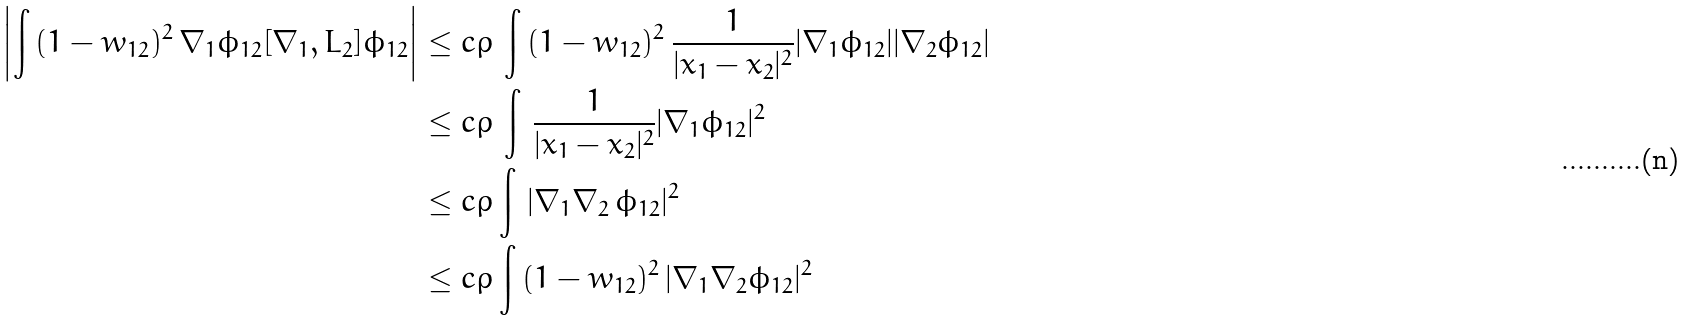Convert formula to latex. <formula><loc_0><loc_0><loc_500><loc_500>\left | \int \, ( 1 - w _ { 1 2 } ) ^ { 2 } \, \nabla _ { 1 } \phi _ { 1 2 } [ \nabla _ { 1 } , L _ { 2 } ] \phi _ { 1 2 } \right | & \leq c \rho \, \int \, ( 1 - w _ { 1 2 } ) ^ { 2 } \, \frac { 1 } { | x _ { 1 } - x _ { 2 } | ^ { 2 } } | \nabla _ { 1 } \phi _ { 1 2 } | | \nabla _ { 2 } \phi _ { 1 2 } | \\ & \leq c \rho \, \int \, \frac { 1 } { | x _ { 1 } - x _ { 2 } | ^ { 2 } } | \nabla _ { 1 } \phi _ { 1 2 } | ^ { 2 } \\ & \leq c \rho \int \, | \nabla _ { 1 } \nabla _ { 2 } \, \phi _ { 1 2 } | ^ { 2 } \\ & \leq c \rho \int \, ( 1 - w _ { 1 2 } ) ^ { 2 } \, | \nabla _ { 1 } \nabla _ { 2 } \phi _ { 1 2 } | ^ { 2 }</formula> 